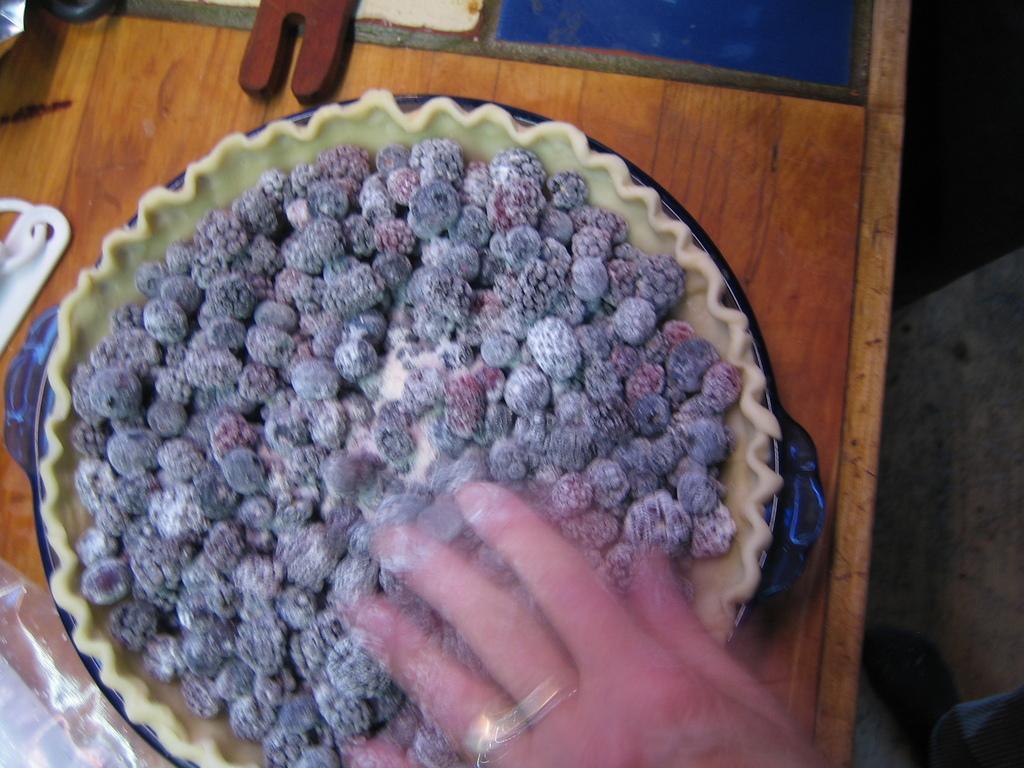Can you describe this image briefly? These are the blueberries, which are on the plate. I can see few objects and a plate are placed on the wooden table. At the bottom of the image, I can see a person´is hand and a leg. 